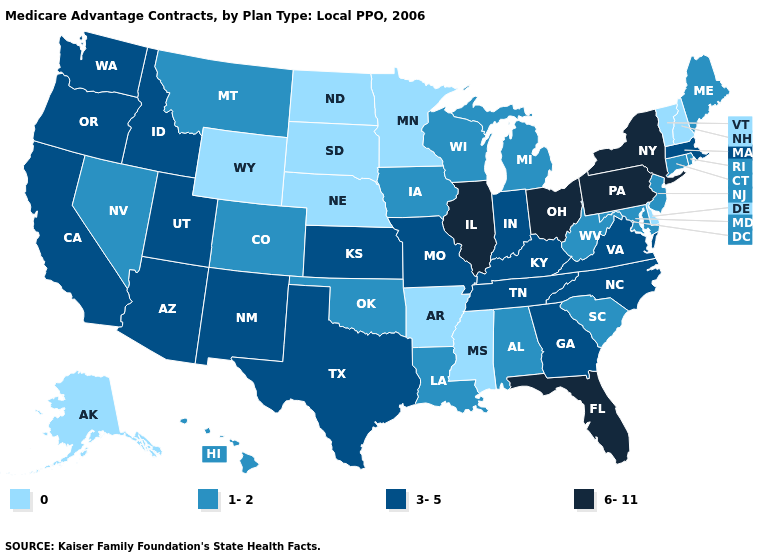Does Missouri have the same value as Tennessee?
Short answer required. Yes. How many symbols are there in the legend?
Give a very brief answer. 4. Name the states that have a value in the range 0?
Concise answer only. Alaska, Arkansas, Delaware, Minnesota, Mississippi, North Dakota, Nebraska, New Hampshire, South Dakota, Vermont, Wyoming. Name the states that have a value in the range 0?
Short answer required. Alaska, Arkansas, Delaware, Minnesota, Mississippi, North Dakota, Nebraska, New Hampshire, South Dakota, Vermont, Wyoming. Which states hav the highest value in the West?
Write a very short answer. Arizona, California, Idaho, New Mexico, Oregon, Utah, Washington. What is the value of South Carolina?
Short answer required. 1-2. Does Washington have a lower value than Pennsylvania?
Be succinct. Yes. What is the value of Massachusetts?
Be succinct. 3-5. What is the value of Vermont?
Quick response, please. 0. What is the highest value in the USA?
Answer briefly. 6-11. Does Alaska have the highest value in the West?
Quick response, please. No. Name the states that have a value in the range 0?
Write a very short answer. Alaska, Arkansas, Delaware, Minnesota, Mississippi, North Dakota, Nebraska, New Hampshire, South Dakota, Vermont, Wyoming. Name the states that have a value in the range 6-11?
Quick response, please. Florida, Illinois, New York, Ohio, Pennsylvania. Is the legend a continuous bar?
Answer briefly. No. What is the value of Maryland?
Be succinct. 1-2. 